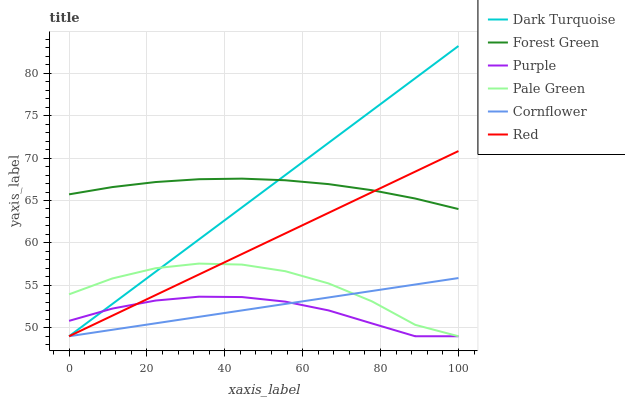Does Purple have the minimum area under the curve?
Answer yes or no. Yes. Does Forest Green have the maximum area under the curve?
Answer yes or no. Yes. Does Dark Turquoise have the minimum area under the curve?
Answer yes or no. No. Does Dark Turquoise have the maximum area under the curve?
Answer yes or no. No. Is Cornflower the smoothest?
Answer yes or no. Yes. Is Pale Green the roughest?
Answer yes or no. Yes. Is Purple the smoothest?
Answer yes or no. No. Is Purple the roughest?
Answer yes or no. No. Does Cornflower have the lowest value?
Answer yes or no. Yes. Does Forest Green have the lowest value?
Answer yes or no. No. Does Dark Turquoise have the highest value?
Answer yes or no. Yes. Does Purple have the highest value?
Answer yes or no. No. Is Cornflower less than Forest Green?
Answer yes or no. Yes. Is Forest Green greater than Pale Green?
Answer yes or no. Yes. Does Red intersect Cornflower?
Answer yes or no. Yes. Is Red less than Cornflower?
Answer yes or no. No. Is Red greater than Cornflower?
Answer yes or no. No. Does Cornflower intersect Forest Green?
Answer yes or no. No. 